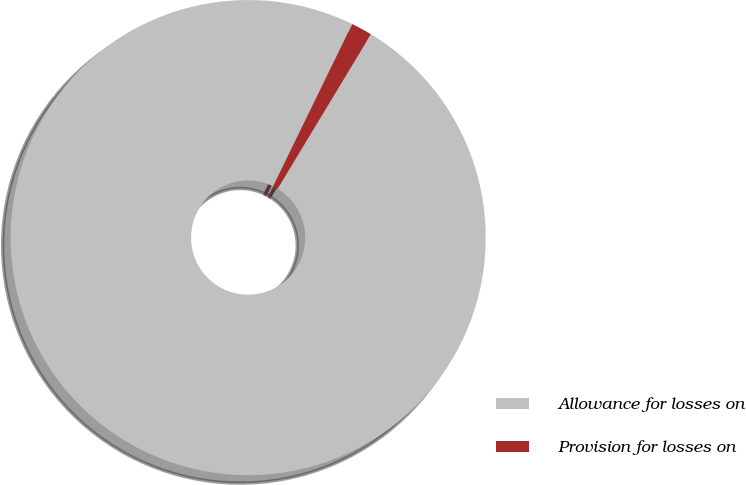Convert chart. <chart><loc_0><loc_0><loc_500><loc_500><pie_chart><fcel>Allowance for losses on<fcel>Provision for losses on<nl><fcel>98.58%<fcel>1.42%<nl></chart> 